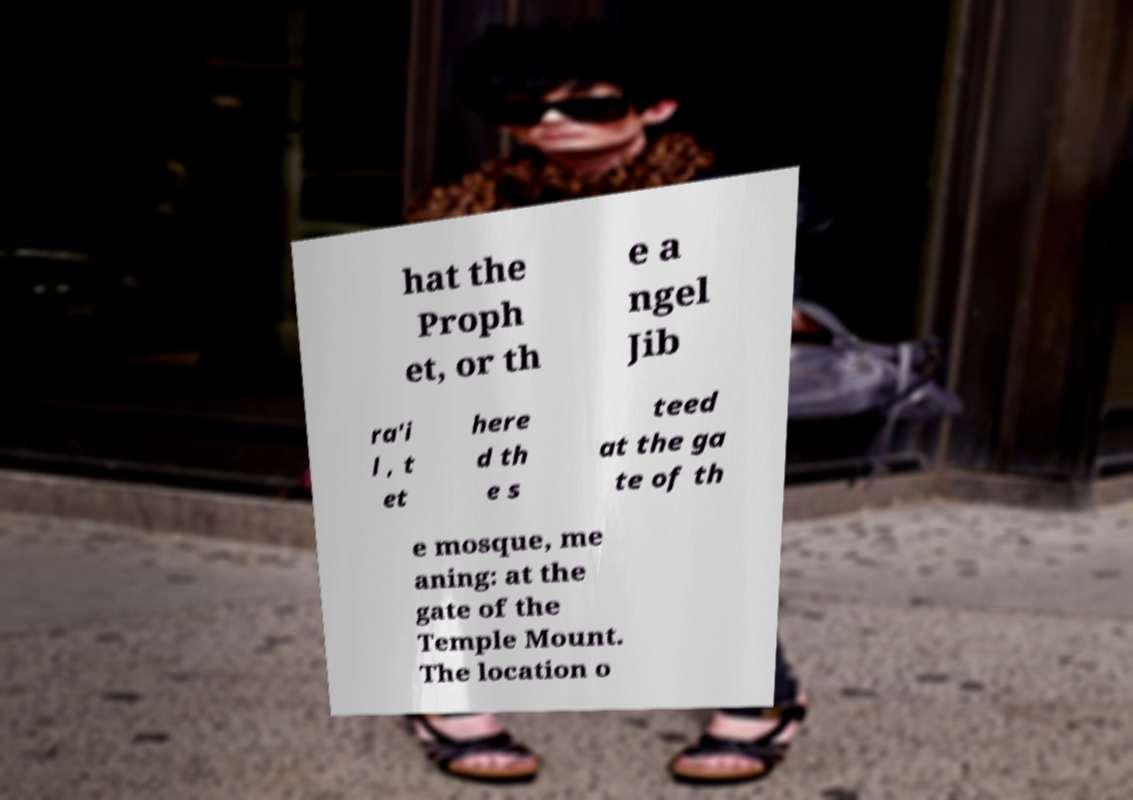Can you read and provide the text displayed in the image?This photo seems to have some interesting text. Can you extract and type it out for me? hat the Proph et, or th e a ngel Jib ra'i l , t et here d th e s teed at the ga te of th e mosque, me aning: at the gate of the Temple Mount. The location o 